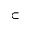<formula> <loc_0><loc_0><loc_500><loc_500>\subset</formula> 